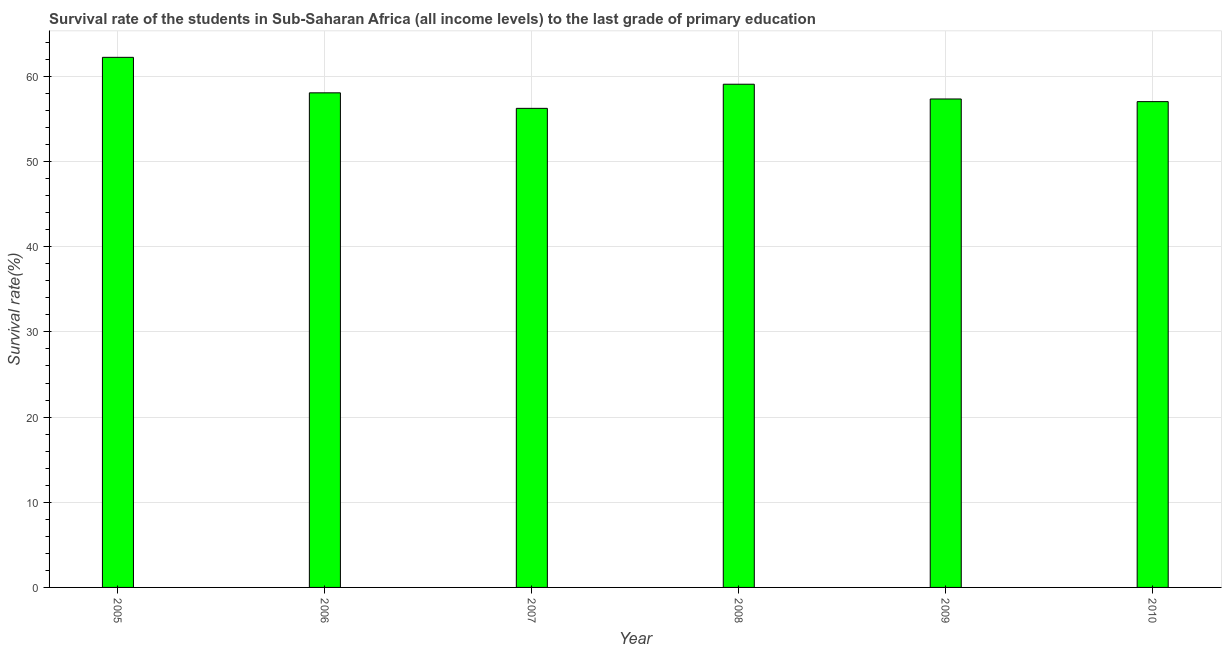What is the title of the graph?
Your answer should be compact. Survival rate of the students in Sub-Saharan Africa (all income levels) to the last grade of primary education. What is the label or title of the X-axis?
Make the answer very short. Year. What is the label or title of the Y-axis?
Your response must be concise. Survival rate(%). What is the survival rate in primary education in 2010?
Give a very brief answer. 57.03. Across all years, what is the maximum survival rate in primary education?
Ensure brevity in your answer.  62.24. Across all years, what is the minimum survival rate in primary education?
Give a very brief answer. 56.25. In which year was the survival rate in primary education maximum?
Keep it short and to the point. 2005. What is the sum of the survival rate in primary education?
Offer a terse response. 350.01. What is the difference between the survival rate in primary education in 2007 and 2009?
Offer a terse response. -1.1. What is the average survival rate in primary education per year?
Your answer should be very brief. 58.34. What is the median survival rate in primary education?
Provide a short and direct response. 57.71. Is the difference between the survival rate in primary education in 2005 and 2008 greater than the difference between any two years?
Your answer should be compact. No. What is the difference between the highest and the second highest survival rate in primary education?
Make the answer very short. 3.16. What is the difference between the highest and the lowest survival rate in primary education?
Your answer should be compact. 5.99. In how many years, is the survival rate in primary education greater than the average survival rate in primary education taken over all years?
Keep it short and to the point. 2. How many bars are there?
Provide a succinct answer. 6. Are all the bars in the graph horizontal?
Make the answer very short. No. What is the Survival rate(%) of 2005?
Keep it short and to the point. 62.24. What is the Survival rate(%) of 2006?
Provide a short and direct response. 58.07. What is the Survival rate(%) in 2007?
Your answer should be very brief. 56.25. What is the Survival rate(%) in 2008?
Your answer should be compact. 59.08. What is the Survival rate(%) in 2009?
Your response must be concise. 57.35. What is the Survival rate(%) in 2010?
Provide a succinct answer. 57.03. What is the difference between the Survival rate(%) in 2005 and 2006?
Your response must be concise. 4.17. What is the difference between the Survival rate(%) in 2005 and 2007?
Provide a short and direct response. 5.99. What is the difference between the Survival rate(%) in 2005 and 2008?
Your answer should be very brief. 3.16. What is the difference between the Survival rate(%) in 2005 and 2009?
Provide a succinct answer. 4.89. What is the difference between the Survival rate(%) in 2005 and 2010?
Your answer should be compact. 5.2. What is the difference between the Survival rate(%) in 2006 and 2007?
Offer a very short reply. 1.82. What is the difference between the Survival rate(%) in 2006 and 2008?
Your response must be concise. -1.01. What is the difference between the Survival rate(%) in 2006 and 2009?
Your response must be concise. 0.72. What is the difference between the Survival rate(%) in 2006 and 2010?
Make the answer very short. 1.03. What is the difference between the Survival rate(%) in 2007 and 2008?
Give a very brief answer. -2.83. What is the difference between the Survival rate(%) in 2007 and 2009?
Offer a terse response. -1.1. What is the difference between the Survival rate(%) in 2007 and 2010?
Make the answer very short. -0.79. What is the difference between the Survival rate(%) in 2008 and 2009?
Your answer should be very brief. 1.73. What is the difference between the Survival rate(%) in 2008 and 2010?
Make the answer very short. 2.04. What is the difference between the Survival rate(%) in 2009 and 2010?
Keep it short and to the point. 0.31. What is the ratio of the Survival rate(%) in 2005 to that in 2006?
Keep it short and to the point. 1.07. What is the ratio of the Survival rate(%) in 2005 to that in 2007?
Offer a very short reply. 1.11. What is the ratio of the Survival rate(%) in 2005 to that in 2008?
Give a very brief answer. 1.05. What is the ratio of the Survival rate(%) in 2005 to that in 2009?
Your response must be concise. 1.08. What is the ratio of the Survival rate(%) in 2005 to that in 2010?
Your answer should be compact. 1.09. What is the ratio of the Survival rate(%) in 2006 to that in 2007?
Your answer should be very brief. 1.03. What is the ratio of the Survival rate(%) in 2006 to that in 2008?
Offer a very short reply. 0.98. What is the ratio of the Survival rate(%) in 2006 to that in 2010?
Your answer should be compact. 1.02. What is the ratio of the Survival rate(%) in 2007 to that in 2008?
Offer a terse response. 0.95. What is the ratio of the Survival rate(%) in 2007 to that in 2010?
Provide a succinct answer. 0.99. What is the ratio of the Survival rate(%) in 2008 to that in 2010?
Provide a short and direct response. 1.04. 